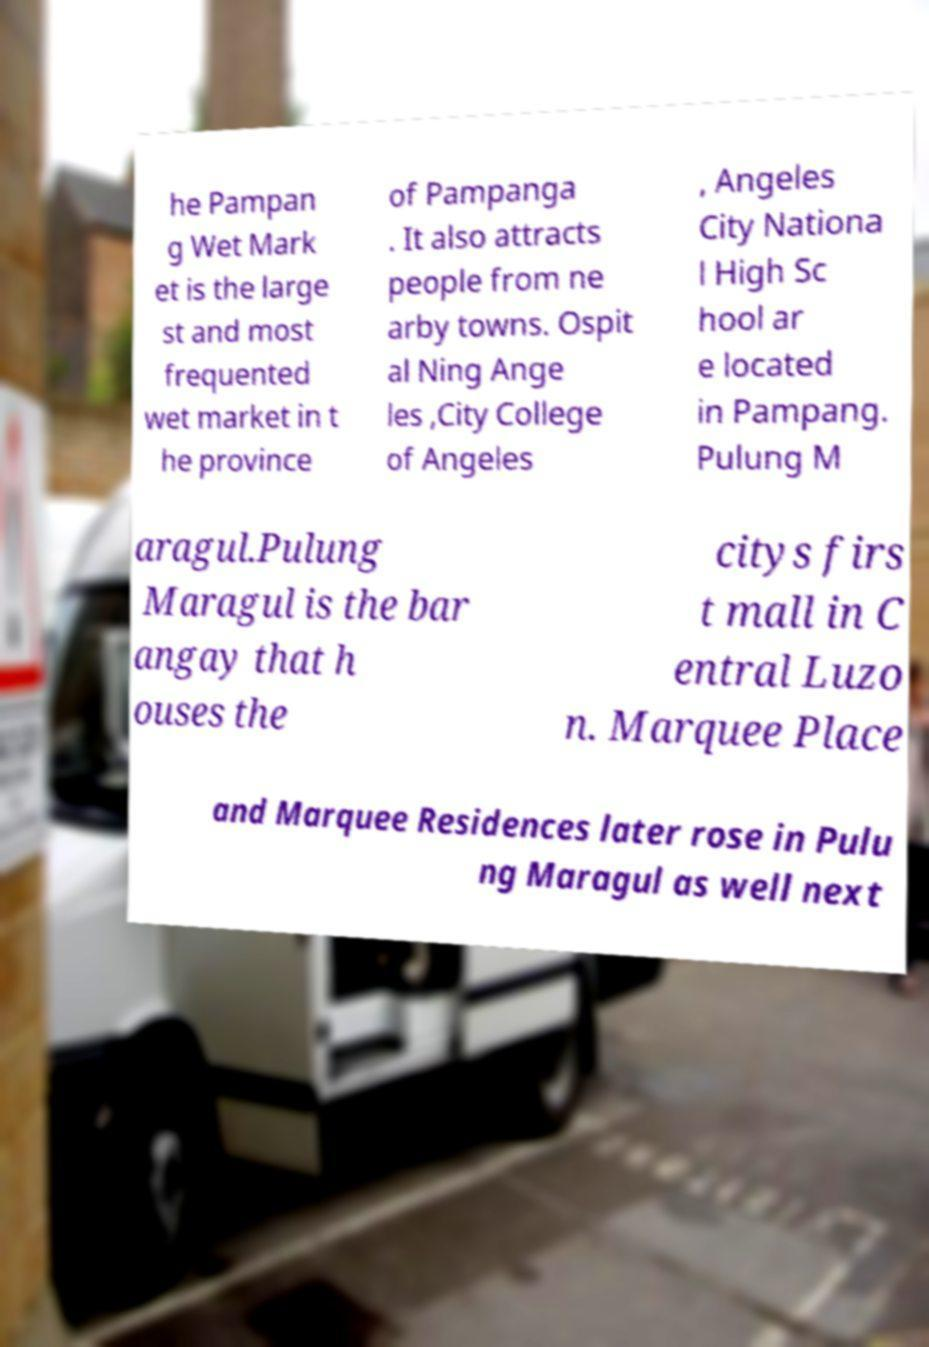For documentation purposes, I need the text within this image transcribed. Could you provide that? he Pampan g Wet Mark et is the large st and most frequented wet market in t he province of Pampanga . It also attracts people from ne arby towns. Ospit al Ning Ange les ,City College of Angeles , Angeles City Nationa l High Sc hool ar e located in Pampang. Pulung M aragul.Pulung Maragul is the bar angay that h ouses the citys firs t mall in C entral Luzo n. Marquee Place and Marquee Residences later rose in Pulu ng Maragul as well next 